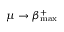Convert formula to latex. <formula><loc_0><loc_0><loc_500><loc_500>\mu \to \beta _ { \max } ^ { + }</formula> 